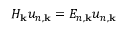<formula> <loc_0><loc_0><loc_500><loc_500>H _ { k } u _ { n , k } = E _ { n , k } u _ { n , k }</formula> 